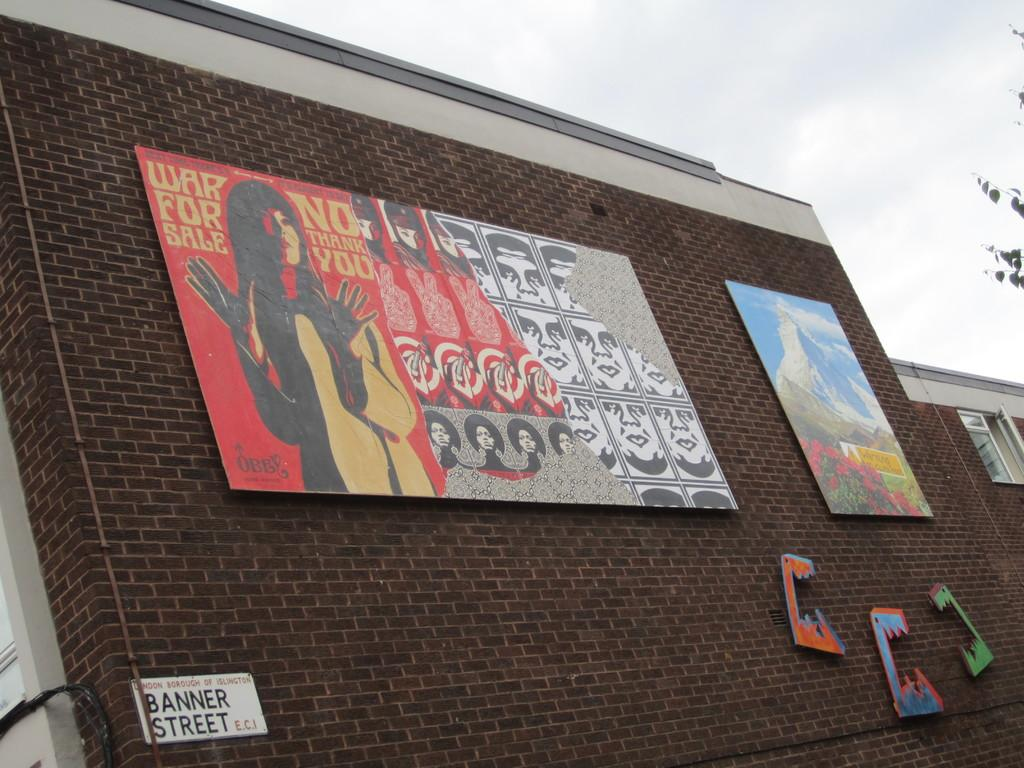What structure is the main subject of the image? There is a building in the image. What can be seen attached to the wall of the building? There are posters attached to the wall of the building. What is visible at the top of the image? The sky is visible at the top of the image. What type of vegetation is on the right side of the image? There are stems with leaves on the right side of the image. What degrees are required to understand the posters in the image? The posters in the image do not require any specific degrees to understand them; they are visual displays. How many pigs can be seen in the image? There are no pigs present in the image. 